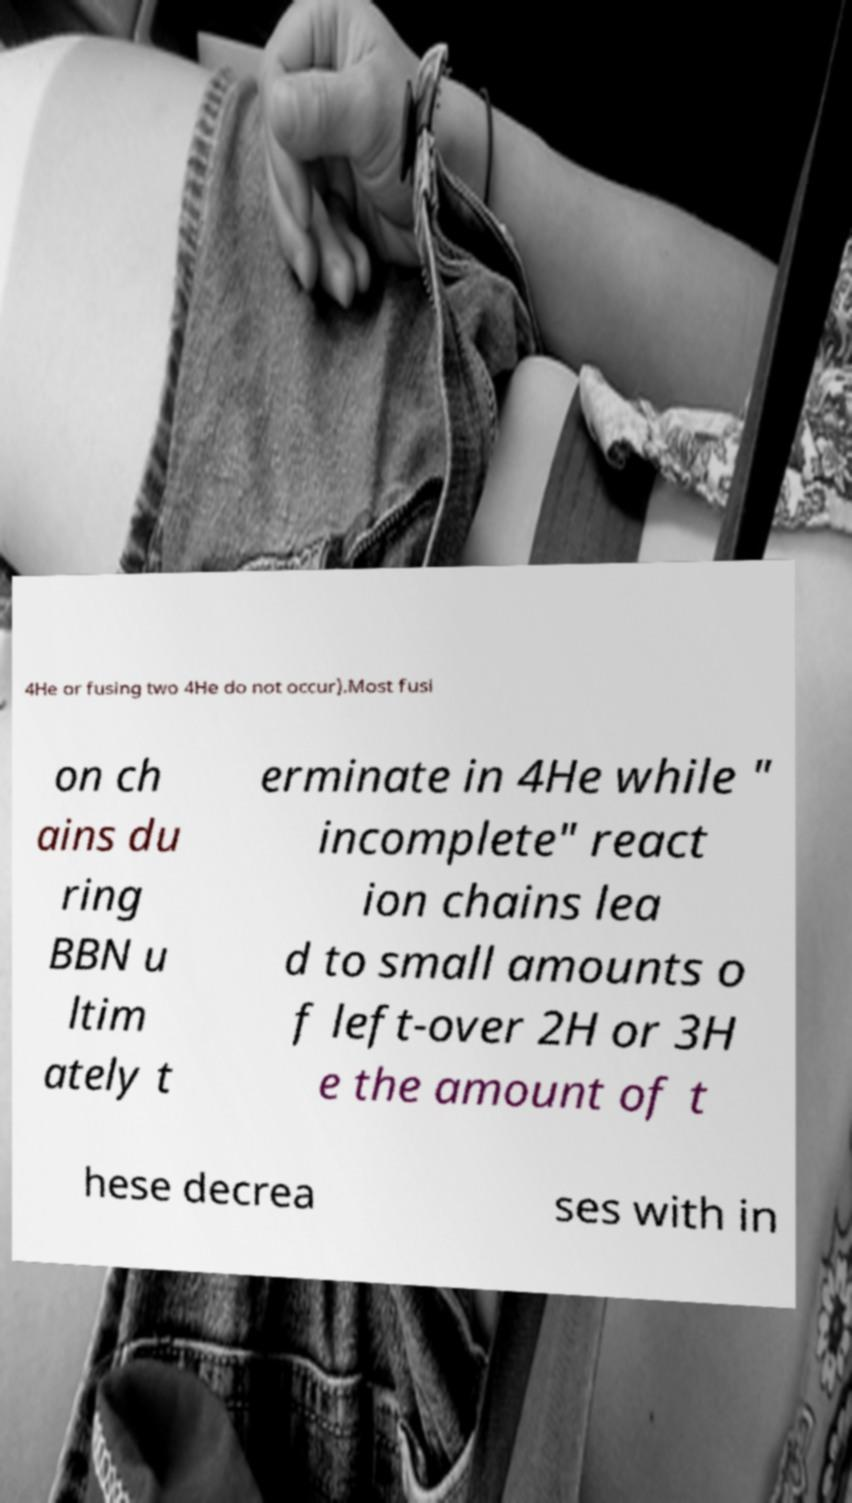Could you extract and type out the text from this image? 4He or fusing two 4He do not occur).Most fusi on ch ains du ring BBN u ltim ately t erminate in 4He while " incomplete" react ion chains lea d to small amounts o f left-over 2H or 3H e the amount of t hese decrea ses with in 